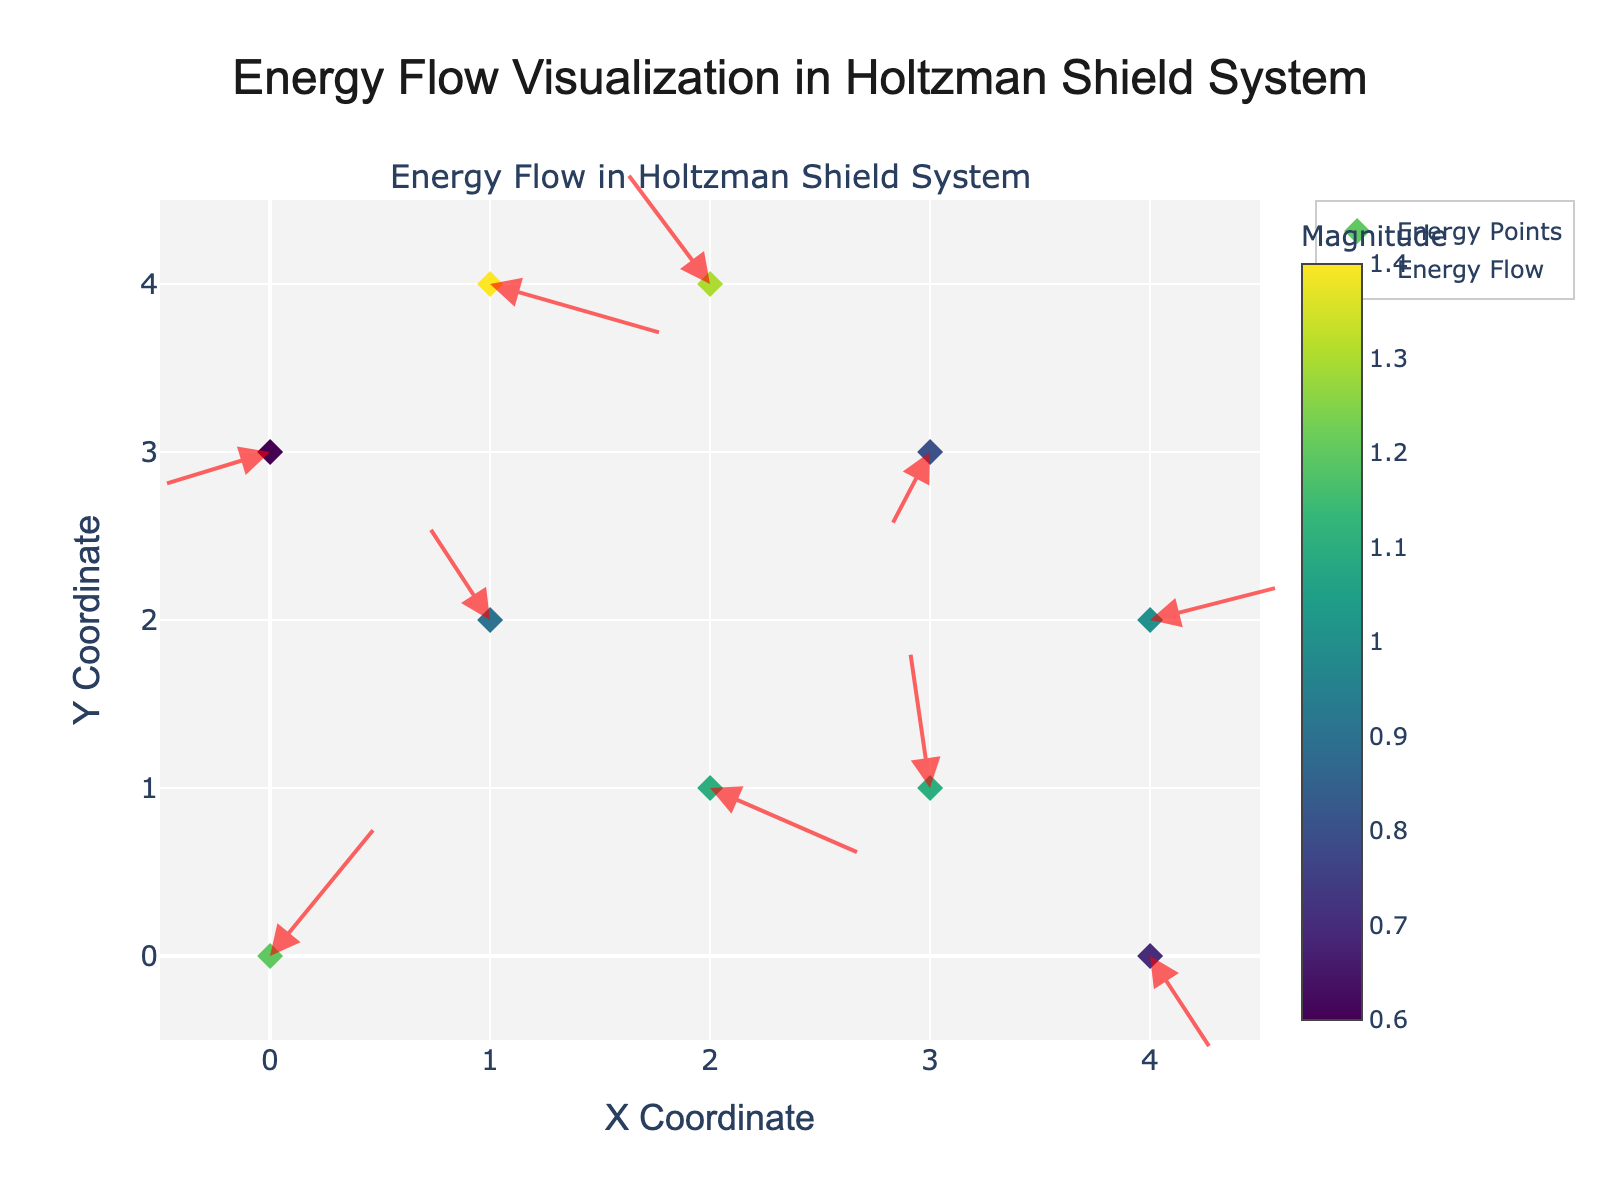what is the title of this plot? The title is often located at the top of the figure and provides a summary of what is being visualized.
Answer: Energy Flow Visualization in Holtzman Shield System How many energy points are visualized in the plot? Count the number of data points (or markers) visible in the visualization.
Answer: 10 What are the colors representing on the marker points? Look at the colorbar and check its title, which will indicate what the colors represent on the plot.
Answer: Magnitude Which data point has the largest magnitude? Look at the colors of the points and refer to the colorbar. The point with the darkest color will have the largest magnitude. Here, it's the point with coordinates (1, 4).
Answer: (1, 4) What's the median x-coordinate of the energy points? To find the median, list all x-coordinates in numerical order and find the middle value. The x-coordinates are [0, 0, 1, 1, 2, 2, 3, 3, 4, 4]. The median values are the middle two values (2 + 2) / 2 = 2.
Answer: 2 Which axis has a wider range in the plot? Check the axis ranges given in the plot's layout. Compare the ranges of the x-axis and y-axis; both range from -0.5 to 4.5. Thus, they have the same range.
Answer: Both are the same What's the direction of the energy flow for the point at (2, 1)? Look at the arrow originating from point (2, 1). It points towards (2 + 0.7, 1 - 0.4), which is (2.7, 0.6). So, the flow is towards the right and down.
Answer: Right and down Compare the energy flow magnitudes of the points at (0, 0) and (1, 4). Which one is higher? Look at the colors and refer to the colorbar. The point at (1, 4) has a darker color indicating higher magnitude (1.4) compared to (0, 0) which has a magnitude of 1.2.
Answer: (1, 4) What is the closest distance between any two points? Manually calculate the distances between all pairs of points. For simplicity, compare the two closest: (1, 2) and (0, 0). Distance = √((1-0)^2 + (2-0)^2) = √1 + 4 = √5 ≈ 2.236. Without visualization, further precision requires numerical methods.
Answer: Approximately 2.236 How is the magnitude visually differentiated in this plot? Look at the plot representation and markers. They are colored according to the magnitude and have a corresponding colorbar.
Answer: By color 